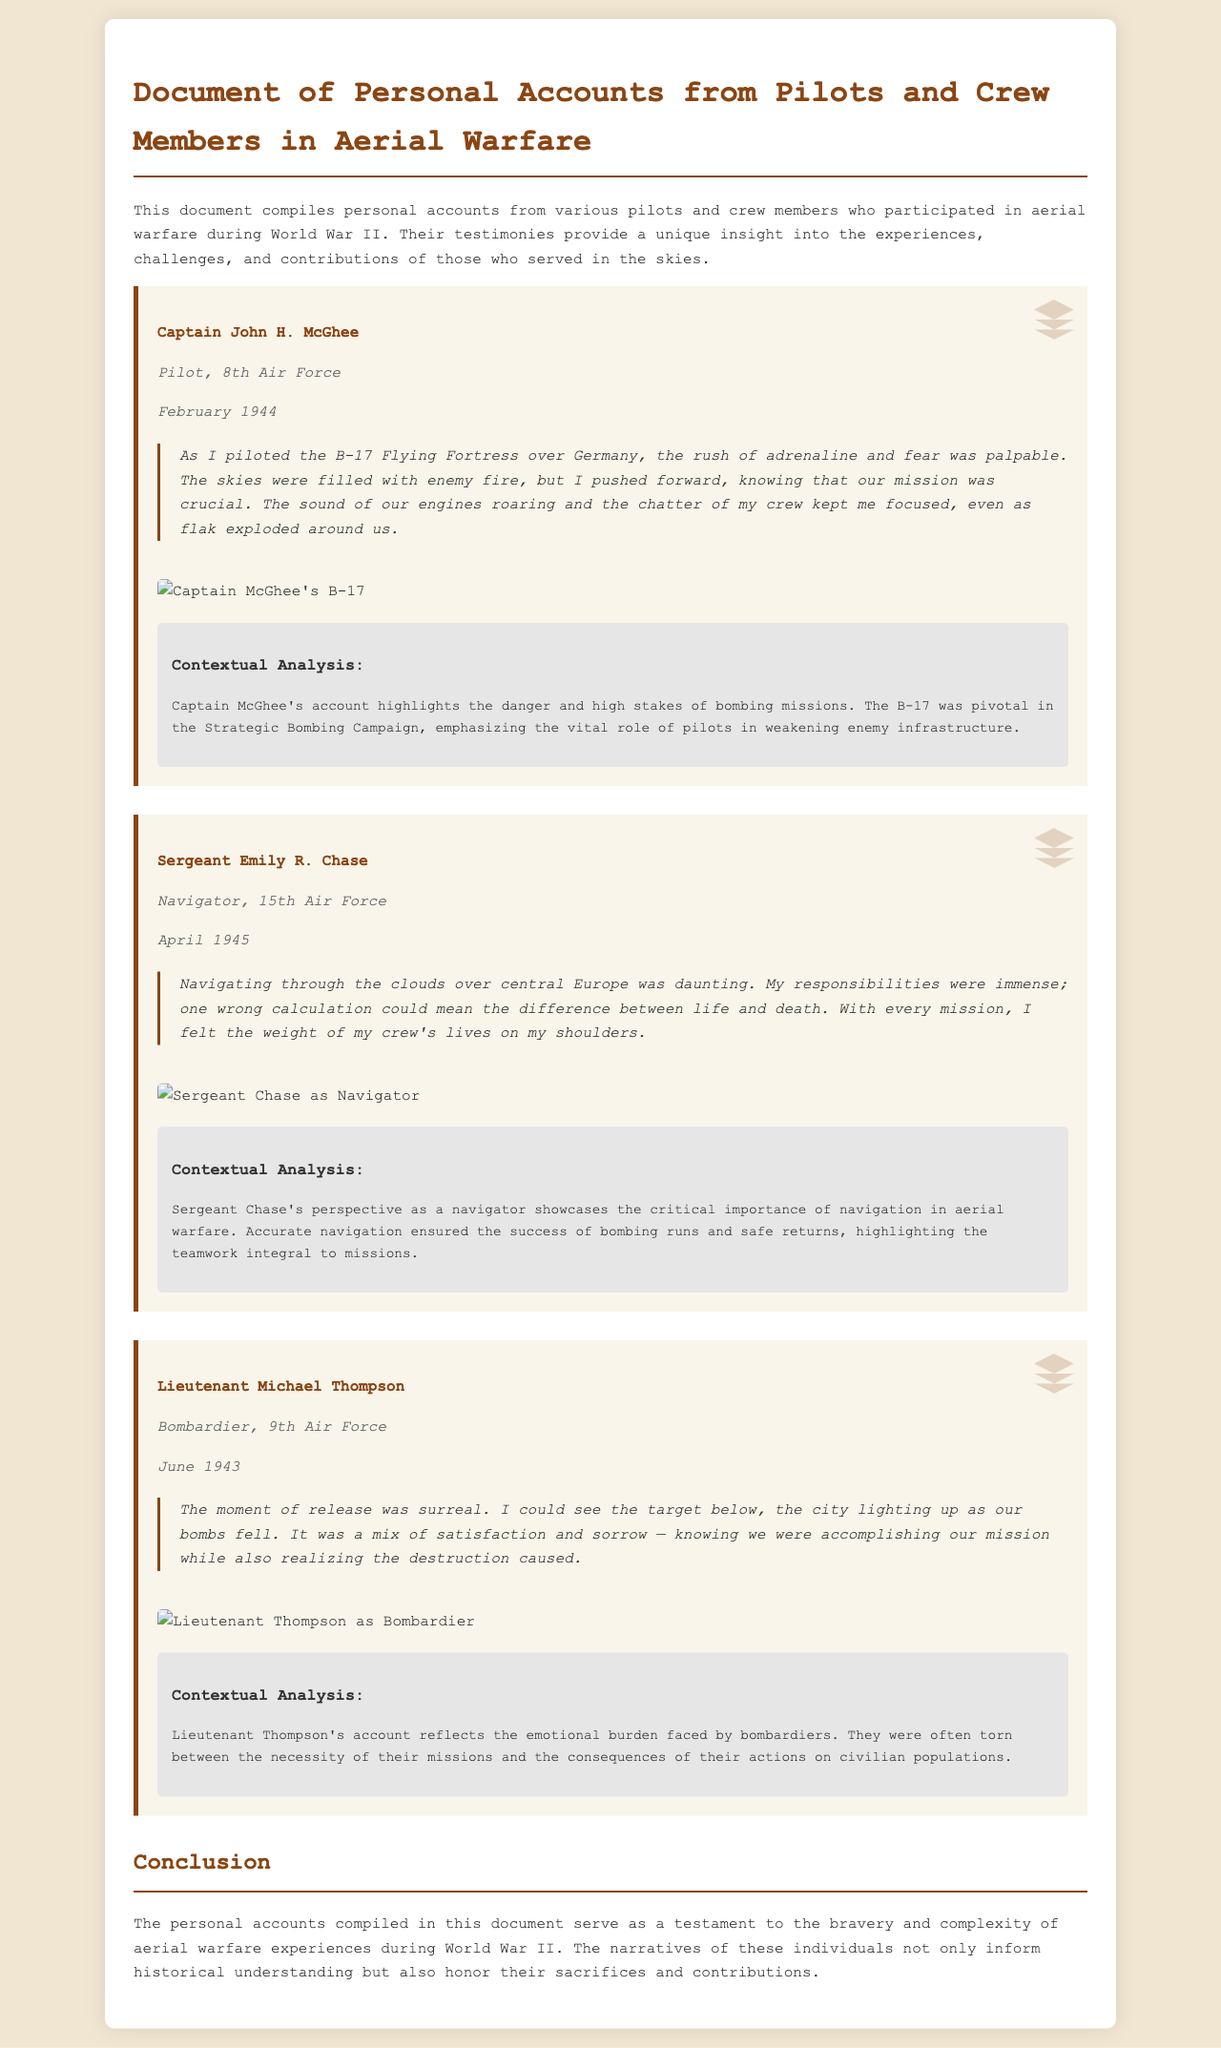What is the name of the pilot mentioned in the document? The document lists Captain John H. McGhee as a pilot's name.
Answer: Captain John H. McGhee What was the date of Sergeant Chase's account? Sergeant Chase's account is dated April 1945.
Answer: April 1945 Which aircraft did Captain McGhee pilot? The document states that he piloted the B-17 Flying Fortress.
Answer: B-17 Flying Fortress What role did Lieutenant Thompson have? Lieutenant Thompson is identified as a bombardier in the document.
Answer: Bombardier How did Sergeant Chase describe her responsibilities? She mentioned that one wrong calculation could mean the difference between life and death.
Answer: One wrong calculation could mean life or death What is the primary theme of the personal accounts compiled in the document? The primary theme reflects bravery and the emotional burden of aerial warfare experiences.
Answer: Bravery and emotional burden of aerial warfare What emotional conflict did Lieutenant Thompson express in his account? He expressed a mix of satisfaction and sorrow regarding the destruction caused by bombing.
Answer: Satisfaction and sorrow What is the significance of accurate navigation in aerial warfare, according to the document? Accurate navigation ensured the success of bombing runs and safe returns.
Answer: Success of bombing runs and safe returns What type of document is this? The document compiles personal accounts from pilots and crew members during World War II.
Answer: Personal accounts from pilots and crew members 